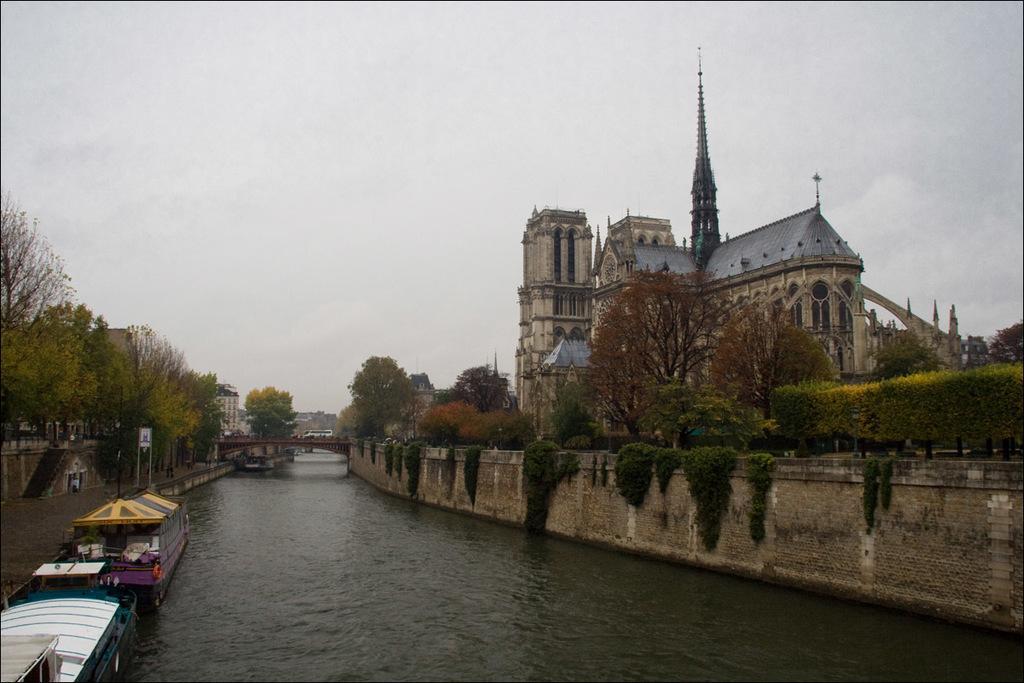Can you describe this image briefly? In this image there are boats on a lake, on either side of the there are walls, on that walls there are plants and trees and there is a bridge across the lake, on the right side there is a building in the background there is the sky. 